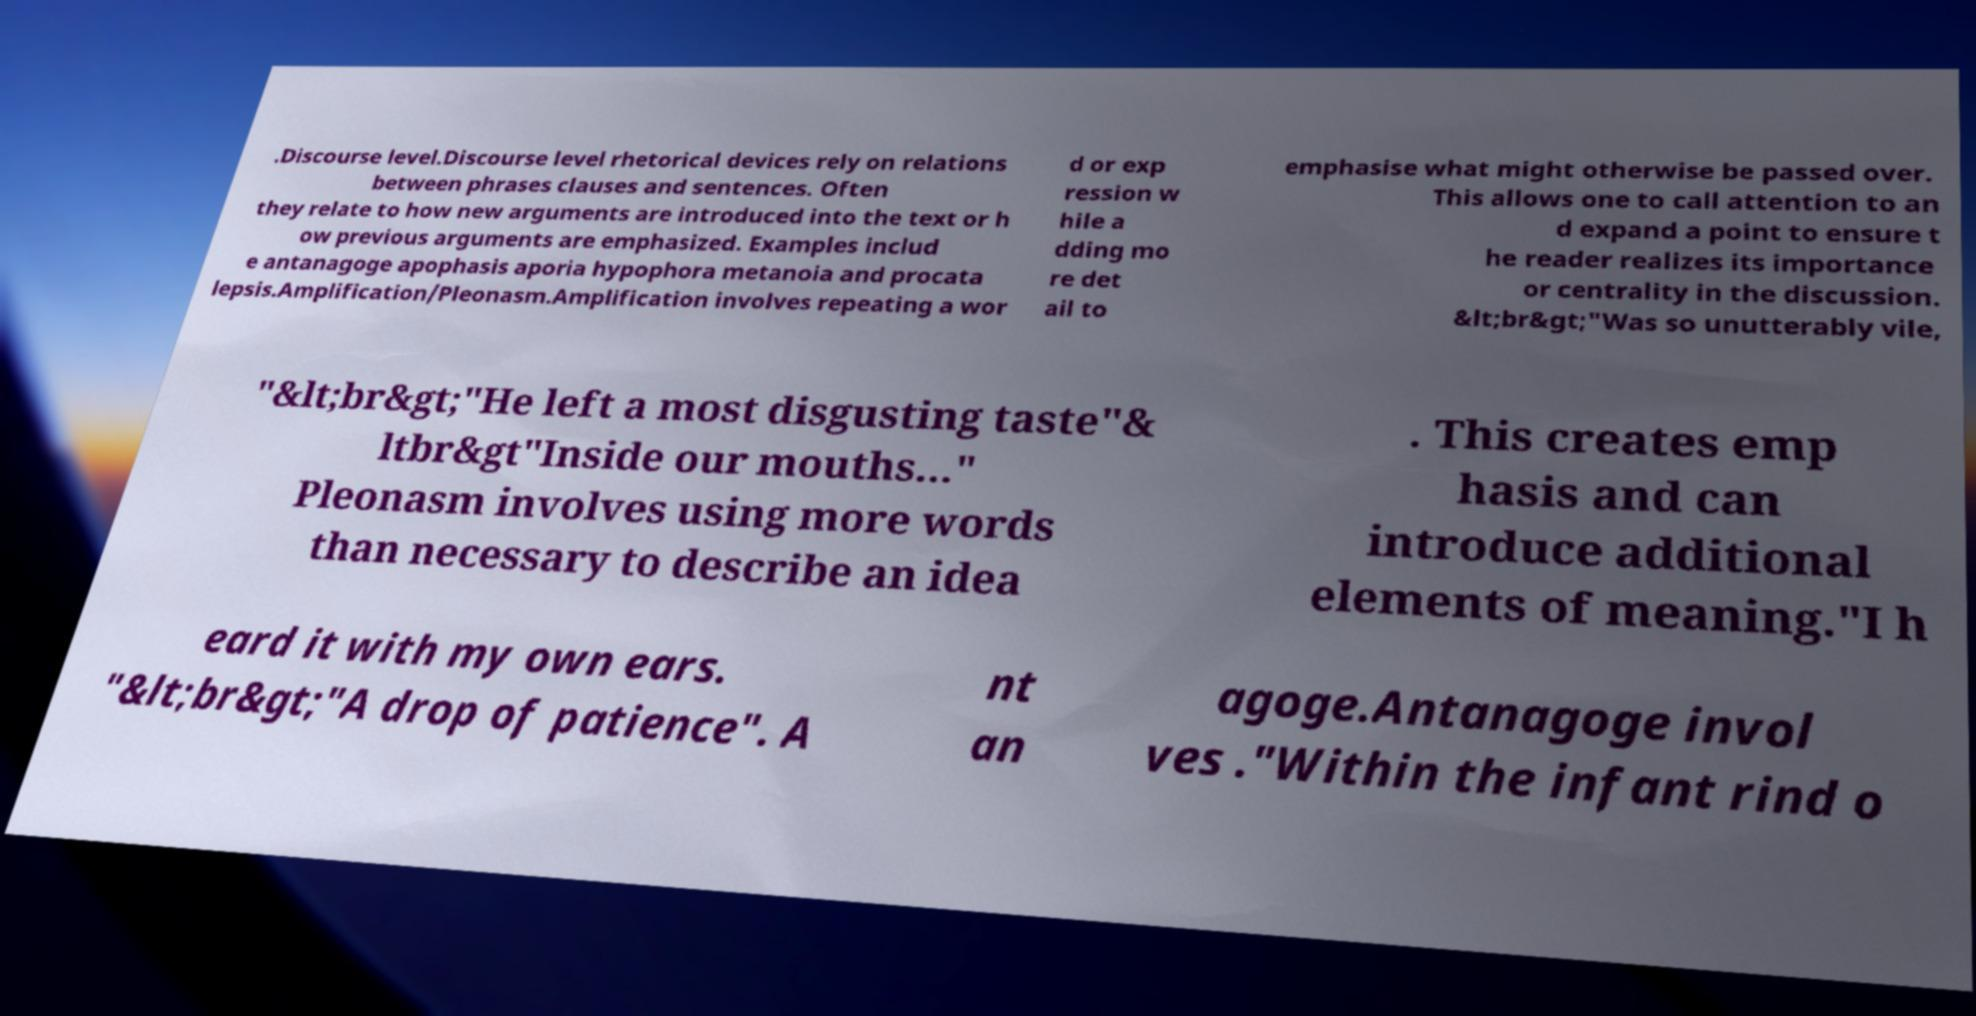Could you extract and type out the text from this image? .Discourse level.Discourse level rhetorical devices rely on relations between phrases clauses and sentences. Often they relate to how new arguments are introduced into the text or h ow previous arguments are emphasized. Examples includ e antanagoge apophasis aporia hypophora metanoia and procata lepsis.Amplification/Pleonasm.Amplification involves repeating a wor d or exp ression w hile a dding mo re det ail to emphasise what might otherwise be passed over. This allows one to call attention to an d expand a point to ensure t he reader realizes its importance or centrality in the discussion. &lt;br&gt;"Was so unutterably vile, "&lt;br&gt;"He left a most disgusting taste"& ltbr&gt"Inside our mouths..." Pleonasm involves using more words than necessary to describe an idea . This creates emp hasis and can introduce additional elements of meaning."I h eard it with my own ears. "&lt;br&gt;"A drop of patience". A nt an agoge.Antanagoge invol ves ."Within the infant rind o 